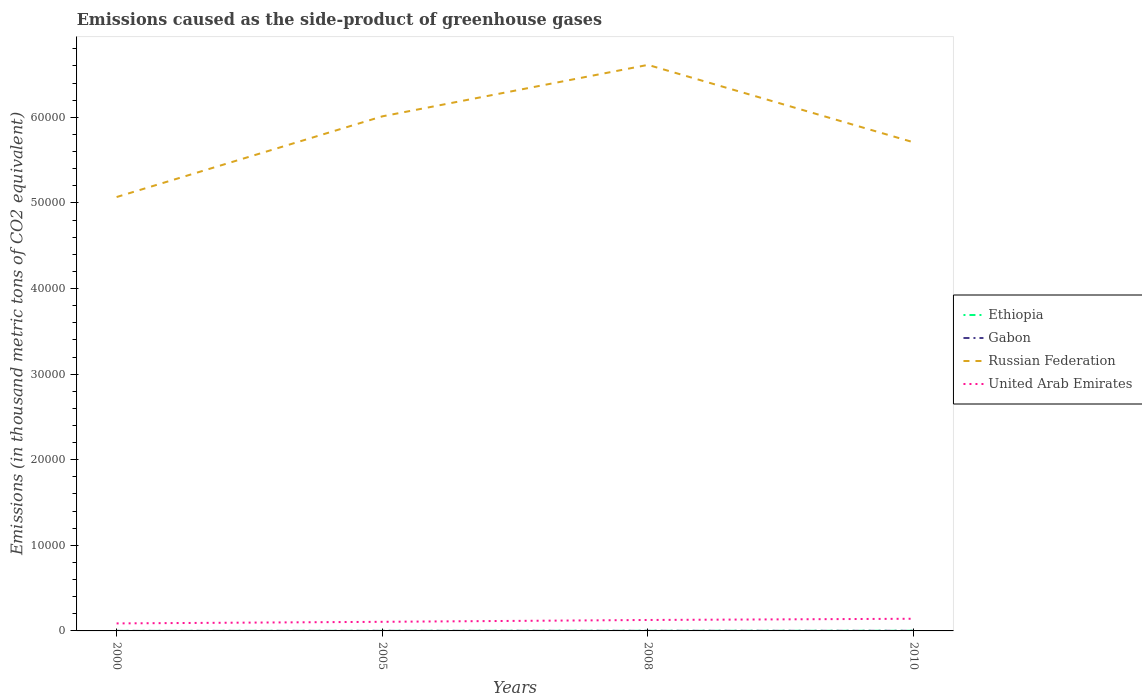How many different coloured lines are there?
Your answer should be very brief. 4. Does the line corresponding to Ethiopia intersect with the line corresponding to United Arab Emirates?
Offer a terse response. No. Across all years, what is the maximum emissions caused as the side-product of greenhouse gases in Russian Federation?
Make the answer very short. 5.07e+04. In which year was the emissions caused as the side-product of greenhouse gases in Ethiopia maximum?
Give a very brief answer. 2000. What is the total emissions caused as the side-product of greenhouse gases in Ethiopia in the graph?
Give a very brief answer. -3. What is the difference between the highest and the second highest emissions caused as the side-product of greenhouse gases in Gabon?
Provide a succinct answer. 11.1. What is the difference between two consecutive major ticks on the Y-axis?
Your answer should be compact. 10000. Are the values on the major ticks of Y-axis written in scientific E-notation?
Make the answer very short. No. Does the graph contain any zero values?
Offer a very short reply. No. Where does the legend appear in the graph?
Offer a very short reply. Center right. How many legend labels are there?
Offer a very short reply. 4. What is the title of the graph?
Offer a very short reply. Emissions caused as the side-product of greenhouse gases. What is the label or title of the Y-axis?
Offer a very short reply. Emissions (in thousand metric tons of CO2 equivalent). What is the Emissions (in thousand metric tons of CO2 equivalent) in Ethiopia in 2000?
Ensure brevity in your answer.  3.6. What is the Emissions (in thousand metric tons of CO2 equivalent) of Russian Federation in 2000?
Provide a short and direct response. 5.07e+04. What is the Emissions (in thousand metric tons of CO2 equivalent) in United Arab Emirates in 2000?
Your response must be concise. 878.1. What is the Emissions (in thousand metric tons of CO2 equivalent) of Russian Federation in 2005?
Your answer should be very brief. 6.01e+04. What is the Emissions (in thousand metric tons of CO2 equivalent) of United Arab Emirates in 2005?
Provide a succinct answer. 1064.1. What is the Emissions (in thousand metric tons of CO2 equivalent) of Russian Federation in 2008?
Provide a succinct answer. 6.61e+04. What is the Emissions (in thousand metric tons of CO2 equivalent) in United Arab Emirates in 2008?
Your response must be concise. 1279. What is the Emissions (in thousand metric tons of CO2 equivalent) of Ethiopia in 2010?
Ensure brevity in your answer.  16. What is the Emissions (in thousand metric tons of CO2 equivalent) of Gabon in 2010?
Keep it short and to the point. 14. What is the Emissions (in thousand metric tons of CO2 equivalent) in Russian Federation in 2010?
Offer a very short reply. 5.71e+04. What is the Emissions (in thousand metric tons of CO2 equivalent) of United Arab Emirates in 2010?
Keep it short and to the point. 1422. Across all years, what is the maximum Emissions (in thousand metric tons of CO2 equivalent) of Ethiopia?
Your answer should be compact. 16. Across all years, what is the maximum Emissions (in thousand metric tons of CO2 equivalent) of Gabon?
Provide a short and direct response. 14. Across all years, what is the maximum Emissions (in thousand metric tons of CO2 equivalent) of Russian Federation?
Provide a short and direct response. 6.61e+04. Across all years, what is the maximum Emissions (in thousand metric tons of CO2 equivalent) in United Arab Emirates?
Your answer should be compact. 1422. Across all years, what is the minimum Emissions (in thousand metric tons of CO2 equivalent) in Ethiopia?
Your response must be concise. 3.6. Across all years, what is the minimum Emissions (in thousand metric tons of CO2 equivalent) of Russian Federation?
Your answer should be very brief. 5.07e+04. Across all years, what is the minimum Emissions (in thousand metric tons of CO2 equivalent) in United Arab Emirates?
Your answer should be very brief. 878.1. What is the total Emissions (in thousand metric tons of CO2 equivalent) of Ethiopia in the graph?
Provide a short and direct response. 43.2. What is the total Emissions (in thousand metric tons of CO2 equivalent) of Gabon in the graph?
Your response must be concise. 37.1. What is the total Emissions (in thousand metric tons of CO2 equivalent) in Russian Federation in the graph?
Your answer should be very brief. 2.34e+05. What is the total Emissions (in thousand metric tons of CO2 equivalent) in United Arab Emirates in the graph?
Ensure brevity in your answer.  4643.2. What is the difference between the Emissions (in thousand metric tons of CO2 equivalent) of Gabon in 2000 and that in 2005?
Your answer should be very brief. -5.5. What is the difference between the Emissions (in thousand metric tons of CO2 equivalent) in Russian Federation in 2000 and that in 2005?
Keep it short and to the point. -9424.5. What is the difference between the Emissions (in thousand metric tons of CO2 equivalent) of United Arab Emirates in 2000 and that in 2005?
Give a very brief answer. -186. What is the difference between the Emissions (in thousand metric tons of CO2 equivalent) in Ethiopia in 2000 and that in 2008?
Your response must be concise. -9.7. What is the difference between the Emissions (in thousand metric tons of CO2 equivalent) in Russian Federation in 2000 and that in 2008?
Your response must be concise. -1.54e+04. What is the difference between the Emissions (in thousand metric tons of CO2 equivalent) in United Arab Emirates in 2000 and that in 2008?
Give a very brief answer. -400.9. What is the difference between the Emissions (in thousand metric tons of CO2 equivalent) in Russian Federation in 2000 and that in 2010?
Ensure brevity in your answer.  -6391. What is the difference between the Emissions (in thousand metric tons of CO2 equivalent) of United Arab Emirates in 2000 and that in 2010?
Offer a very short reply. -543.9. What is the difference between the Emissions (in thousand metric tons of CO2 equivalent) of Gabon in 2005 and that in 2008?
Ensure brevity in your answer.  -3.4. What is the difference between the Emissions (in thousand metric tons of CO2 equivalent) in Russian Federation in 2005 and that in 2008?
Your answer should be compact. -6015. What is the difference between the Emissions (in thousand metric tons of CO2 equivalent) in United Arab Emirates in 2005 and that in 2008?
Your response must be concise. -214.9. What is the difference between the Emissions (in thousand metric tons of CO2 equivalent) of Gabon in 2005 and that in 2010?
Provide a short and direct response. -5.6. What is the difference between the Emissions (in thousand metric tons of CO2 equivalent) of Russian Federation in 2005 and that in 2010?
Ensure brevity in your answer.  3033.5. What is the difference between the Emissions (in thousand metric tons of CO2 equivalent) of United Arab Emirates in 2005 and that in 2010?
Your answer should be very brief. -357.9. What is the difference between the Emissions (in thousand metric tons of CO2 equivalent) of Gabon in 2008 and that in 2010?
Your answer should be compact. -2.2. What is the difference between the Emissions (in thousand metric tons of CO2 equivalent) in Russian Federation in 2008 and that in 2010?
Keep it short and to the point. 9048.5. What is the difference between the Emissions (in thousand metric tons of CO2 equivalent) of United Arab Emirates in 2008 and that in 2010?
Your response must be concise. -143. What is the difference between the Emissions (in thousand metric tons of CO2 equivalent) in Ethiopia in 2000 and the Emissions (in thousand metric tons of CO2 equivalent) in Russian Federation in 2005?
Provide a short and direct response. -6.01e+04. What is the difference between the Emissions (in thousand metric tons of CO2 equivalent) of Ethiopia in 2000 and the Emissions (in thousand metric tons of CO2 equivalent) of United Arab Emirates in 2005?
Offer a terse response. -1060.5. What is the difference between the Emissions (in thousand metric tons of CO2 equivalent) of Gabon in 2000 and the Emissions (in thousand metric tons of CO2 equivalent) of Russian Federation in 2005?
Keep it short and to the point. -6.01e+04. What is the difference between the Emissions (in thousand metric tons of CO2 equivalent) of Gabon in 2000 and the Emissions (in thousand metric tons of CO2 equivalent) of United Arab Emirates in 2005?
Keep it short and to the point. -1061.2. What is the difference between the Emissions (in thousand metric tons of CO2 equivalent) of Russian Federation in 2000 and the Emissions (in thousand metric tons of CO2 equivalent) of United Arab Emirates in 2005?
Offer a terse response. 4.96e+04. What is the difference between the Emissions (in thousand metric tons of CO2 equivalent) of Ethiopia in 2000 and the Emissions (in thousand metric tons of CO2 equivalent) of Russian Federation in 2008?
Your answer should be very brief. -6.61e+04. What is the difference between the Emissions (in thousand metric tons of CO2 equivalent) in Ethiopia in 2000 and the Emissions (in thousand metric tons of CO2 equivalent) in United Arab Emirates in 2008?
Keep it short and to the point. -1275.4. What is the difference between the Emissions (in thousand metric tons of CO2 equivalent) in Gabon in 2000 and the Emissions (in thousand metric tons of CO2 equivalent) in Russian Federation in 2008?
Offer a very short reply. -6.61e+04. What is the difference between the Emissions (in thousand metric tons of CO2 equivalent) in Gabon in 2000 and the Emissions (in thousand metric tons of CO2 equivalent) in United Arab Emirates in 2008?
Provide a short and direct response. -1276.1. What is the difference between the Emissions (in thousand metric tons of CO2 equivalent) of Russian Federation in 2000 and the Emissions (in thousand metric tons of CO2 equivalent) of United Arab Emirates in 2008?
Provide a succinct answer. 4.94e+04. What is the difference between the Emissions (in thousand metric tons of CO2 equivalent) of Ethiopia in 2000 and the Emissions (in thousand metric tons of CO2 equivalent) of Russian Federation in 2010?
Keep it short and to the point. -5.71e+04. What is the difference between the Emissions (in thousand metric tons of CO2 equivalent) in Ethiopia in 2000 and the Emissions (in thousand metric tons of CO2 equivalent) in United Arab Emirates in 2010?
Your answer should be very brief. -1418.4. What is the difference between the Emissions (in thousand metric tons of CO2 equivalent) in Gabon in 2000 and the Emissions (in thousand metric tons of CO2 equivalent) in Russian Federation in 2010?
Your answer should be compact. -5.71e+04. What is the difference between the Emissions (in thousand metric tons of CO2 equivalent) in Gabon in 2000 and the Emissions (in thousand metric tons of CO2 equivalent) in United Arab Emirates in 2010?
Your answer should be very brief. -1419.1. What is the difference between the Emissions (in thousand metric tons of CO2 equivalent) in Russian Federation in 2000 and the Emissions (in thousand metric tons of CO2 equivalent) in United Arab Emirates in 2010?
Keep it short and to the point. 4.93e+04. What is the difference between the Emissions (in thousand metric tons of CO2 equivalent) in Ethiopia in 2005 and the Emissions (in thousand metric tons of CO2 equivalent) in Gabon in 2008?
Offer a very short reply. -1.5. What is the difference between the Emissions (in thousand metric tons of CO2 equivalent) in Ethiopia in 2005 and the Emissions (in thousand metric tons of CO2 equivalent) in Russian Federation in 2008?
Your answer should be compact. -6.61e+04. What is the difference between the Emissions (in thousand metric tons of CO2 equivalent) of Ethiopia in 2005 and the Emissions (in thousand metric tons of CO2 equivalent) of United Arab Emirates in 2008?
Provide a short and direct response. -1268.7. What is the difference between the Emissions (in thousand metric tons of CO2 equivalent) of Gabon in 2005 and the Emissions (in thousand metric tons of CO2 equivalent) of Russian Federation in 2008?
Your answer should be very brief. -6.61e+04. What is the difference between the Emissions (in thousand metric tons of CO2 equivalent) of Gabon in 2005 and the Emissions (in thousand metric tons of CO2 equivalent) of United Arab Emirates in 2008?
Your response must be concise. -1270.6. What is the difference between the Emissions (in thousand metric tons of CO2 equivalent) of Russian Federation in 2005 and the Emissions (in thousand metric tons of CO2 equivalent) of United Arab Emirates in 2008?
Your response must be concise. 5.88e+04. What is the difference between the Emissions (in thousand metric tons of CO2 equivalent) in Ethiopia in 2005 and the Emissions (in thousand metric tons of CO2 equivalent) in Russian Federation in 2010?
Offer a terse response. -5.71e+04. What is the difference between the Emissions (in thousand metric tons of CO2 equivalent) of Ethiopia in 2005 and the Emissions (in thousand metric tons of CO2 equivalent) of United Arab Emirates in 2010?
Keep it short and to the point. -1411.7. What is the difference between the Emissions (in thousand metric tons of CO2 equivalent) in Gabon in 2005 and the Emissions (in thousand metric tons of CO2 equivalent) in Russian Federation in 2010?
Ensure brevity in your answer.  -5.71e+04. What is the difference between the Emissions (in thousand metric tons of CO2 equivalent) of Gabon in 2005 and the Emissions (in thousand metric tons of CO2 equivalent) of United Arab Emirates in 2010?
Ensure brevity in your answer.  -1413.6. What is the difference between the Emissions (in thousand metric tons of CO2 equivalent) of Russian Federation in 2005 and the Emissions (in thousand metric tons of CO2 equivalent) of United Arab Emirates in 2010?
Keep it short and to the point. 5.87e+04. What is the difference between the Emissions (in thousand metric tons of CO2 equivalent) of Ethiopia in 2008 and the Emissions (in thousand metric tons of CO2 equivalent) of Gabon in 2010?
Give a very brief answer. -0.7. What is the difference between the Emissions (in thousand metric tons of CO2 equivalent) in Ethiopia in 2008 and the Emissions (in thousand metric tons of CO2 equivalent) in Russian Federation in 2010?
Make the answer very short. -5.71e+04. What is the difference between the Emissions (in thousand metric tons of CO2 equivalent) of Ethiopia in 2008 and the Emissions (in thousand metric tons of CO2 equivalent) of United Arab Emirates in 2010?
Your answer should be compact. -1408.7. What is the difference between the Emissions (in thousand metric tons of CO2 equivalent) of Gabon in 2008 and the Emissions (in thousand metric tons of CO2 equivalent) of Russian Federation in 2010?
Give a very brief answer. -5.71e+04. What is the difference between the Emissions (in thousand metric tons of CO2 equivalent) of Gabon in 2008 and the Emissions (in thousand metric tons of CO2 equivalent) of United Arab Emirates in 2010?
Provide a succinct answer. -1410.2. What is the difference between the Emissions (in thousand metric tons of CO2 equivalent) of Russian Federation in 2008 and the Emissions (in thousand metric tons of CO2 equivalent) of United Arab Emirates in 2010?
Offer a very short reply. 6.47e+04. What is the average Emissions (in thousand metric tons of CO2 equivalent) in Ethiopia per year?
Make the answer very short. 10.8. What is the average Emissions (in thousand metric tons of CO2 equivalent) of Gabon per year?
Provide a short and direct response. 9.28. What is the average Emissions (in thousand metric tons of CO2 equivalent) in Russian Federation per year?
Offer a terse response. 5.85e+04. What is the average Emissions (in thousand metric tons of CO2 equivalent) of United Arab Emirates per year?
Your response must be concise. 1160.8. In the year 2000, what is the difference between the Emissions (in thousand metric tons of CO2 equivalent) in Ethiopia and Emissions (in thousand metric tons of CO2 equivalent) in Gabon?
Provide a short and direct response. 0.7. In the year 2000, what is the difference between the Emissions (in thousand metric tons of CO2 equivalent) in Ethiopia and Emissions (in thousand metric tons of CO2 equivalent) in Russian Federation?
Your answer should be very brief. -5.07e+04. In the year 2000, what is the difference between the Emissions (in thousand metric tons of CO2 equivalent) in Ethiopia and Emissions (in thousand metric tons of CO2 equivalent) in United Arab Emirates?
Offer a terse response. -874.5. In the year 2000, what is the difference between the Emissions (in thousand metric tons of CO2 equivalent) in Gabon and Emissions (in thousand metric tons of CO2 equivalent) in Russian Federation?
Make the answer very short. -5.07e+04. In the year 2000, what is the difference between the Emissions (in thousand metric tons of CO2 equivalent) of Gabon and Emissions (in thousand metric tons of CO2 equivalent) of United Arab Emirates?
Ensure brevity in your answer.  -875.2. In the year 2000, what is the difference between the Emissions (in thousand metric tons of CO2 equivalent) in Russian Federation and Emissions (in thousand metric tons of CO2 equivalent) in United Arab Emirates?
Offer a very short reply. 4.98e+04. In the year 2005, what is the difference between the Emissions (in thousand metric tons of CO2 equivalent) in Ethiopia and Emissions (in thousand metric tons of CO2 equivalent) in Gabon?
Your answer should be very brief. 1.9. In the year 2005, what is the difference between the Emissions (in thousand metric tons of CO2 equivalent) of Ethiopia and Emissions (in thousand metric tons of CO2 equivalent) of Russian Federation?
Ensure brevity in your answer.  -6.01e+04. In the year 2005, what is the difference between the Emissions (in thousand metric tons of CO2 equivalent) in Ethiopia and Emissions (in thousand metric tons of CO2 equivalent) in United Arab Emirates?
Your answer should be very brief. -1053.8. In the year 2005, what is the difference between the Emissions (in thousand metric tons of CO2 equivalent) in Gabon and Emissions (in thousand metric tons of CO2 equivalent) in Russian Federation?
Offer a terse response. -6.01e+04. In the year 2005, what is the difference between the Emissions (in thousand metric tons of CO2 equivalent) in Gabon and Emissions (in thousand metric tons of CO2 equivalent) in United Arab Emirates?
Make the answer very short. -1055.7. In the year 2005, what is the difference between the Emissions (in thousand metric tons of CO2 equivalent) of Russian Federation and Emissions (in thousand metric tons of CO2 equivalent) of United Arab Emirates?
Your answer should be compact. 5.90e+04. In the year 2008, what is the difference between the Emissions (in thousand metric tons of CO2 equivalent) in Ethiopia and Emissions (in thousand metric tons of CO2 equivalent) in Russian Federation?
Ensure brevity in your answer.  -6.61e+04. In the year 2008, what is the difference between the Emissions (in thousand metric tons of CO2 equivalent) in Ethiopia and Emissions (in thousand metric tons of CO2 equivalent) in United Arab Emirates?
Make the answer very short. -1265.7. In the year 2008, what is the difference between the Emissions (in thousand metric tons of CO2 equivalent) of Gabon and Emissions (in thousand metric tons of CO2 equivalent) of Russian Federation?
Your answer should be very brief. -6.61e+04. In the year 2008, what is the difference between the Emissions (in thousand metric tons of CO2 equivalent) of Gabon and Emissions (in thousand metric tons of CO2 equivalent) of United Arab Emirates?
Give a very brief answer. -1267.2. In the year 2008, what is the difference between the Emissions (in thousand metric tons of CO2 equivalent) in Russian Federation and Emissions (in thousand metric tons of CO2 equivalent) in United Arab Emirates?
Make the answer very short. 6.48e+04. In the year 2010, what is the difference between the Emissions (in thousand metric tons of CO2 equivalent) of Ethiopia and Emissions (in thousand metric tons of CO2 equivalent) of Gabon?
Provide a short and direct response. 2. In the year 2010, what is the difference between the Emissions (in thousand metric tons of CO2 equivalent) in Ethiopia and Emissions (in thousand metric tons of CO2 equivalent) in Russian Federation?
Your answer should be compact. -5.71e+04. In the year 2010, what is the difference between the Emissions (in thousand metric tons of CO2 equivalent) of Ethiopia and Emissions (in thousand metric tons of CO2 equivalent) of United Arab Emirates?
Make the answer very short. -1406. In the year 2010, what is the difference between the Emissions (in thousand metric tons of CO2 equivalent) of Gabon and Emissions (in thousand metric tons of CO2 equivalent) of Russian Federation?
Your answer should be very brief. -5.71e+04. In the year 2010, what is the difference between the Emissions (in thousand metric tons of CO2 equivalent) in Gabon and Emissions (in thousand metric tons of CO2 equivalent) in United Arab Emirates?
Give a very brief answer. -1408. In the year 2010, what is the difference between the Emissions (in thousand metric tons of CO2 equivalent) in Russian Federation and Emissions (in thousand metric tons of CO2 equivalent) in United Arab Emirates?
Give a very brief answer. 5.57e+04. What is the ratio of the Emissions (in thousand metric tons of CO2 equivalent) of Ethiopia in 2000 to that in 2005?
Provide a short and direct response. 0.35. What is the ratio of the Emissions (in thousand metric tons of CO2 equivalent) of Gabon in 2000 to that in 2005?
Provide a succinct answer. 0.35. What is the ratio of the Emissions (in thousand metric tons of CO2 equivalent) of Russian Federation in 2000 to that in 2005?
Your answer should be very brief. 0.84. What is the ratio of the Emissions (in thousand metric tons of CO2 equivalent) in United Arab Emirates in 2000 to that in 2005?
Give a very brief answer. 0.83. What is the ratio of the Emissions (in thousand metric tons of CO2 equivalent) in Ethiopia in 2000 to that in 2008?
Offer a terse response. 0.27. What is the ratio of the Emissions (in thousand metric tons of CO2 equivalent) in Gabon in 2000 to that in 2008?
Give a very brief answer. 0.25. What is the ratio of the Emissions (in thousand metric tons of CO2 equivalent) in Russian Federation in 2000 to that in 2008?
Offer a terse response. 0.77. What is the ratio of the Emissions (in thousand metric tons of CO2 equivalent) in United Arab Emirates in 2000 to that in 2008?
Make the answer very short. 0.69. What is the ratio of the Emissions (in thousand metric tons of CO2 equivalent) in Ethiopia in 2000 to that in 2010?
Make the answer very short. 0.23. What is the ratio of the Emissions (in thousand metric tons of CO2 equivalent) in Gabon in 2000 to that in 2010?
Offer a terse response. 0.21. What is the ratio of the Emissions (in thousand metric tons of CO2 equivalent) of Russian Federation in 2000 to that in 2010?
Keep it short and to the point. 0.89. What is the ratio of the Emissions (in thousand metric tons of CO2 equivalent) of United Arab Emirates in 2000 to that in 2010?
Provide a short and direct response. 0.62. What is the ratio of the Emissions (in thousand metric tons of CO2 equivalent) of Ethiopia in 2005 to that in 2008?
Your answer should be compact. 0.77. What is the ratio of the Emissions (in thousand metric tons of CO2 equivalent) of Gabon in 2005 to that in 2008?
Provide a short and direct response. 0.71. What is the ratio of the Emissions (in thousand metric tons of CO2 equivalent) in Russian Federation in 2005 to that in 2008?
Your answer should be very brief. 0.91. What is the ratio of the Emissions (in thousand metric tons of CO2 equivalent) of United Arab Emirates in 2005 to that in 2008?
Your answer should be very brief. 0.83. What is the ratio of the Emissions (in thousand metric tons of CO2 equivalent) of Ethiopia in 2005 to that in 2010?
Your answer should be very brief. 0.64. What is the ratio of the Emissions (in thousand metric tons of CO2 equivalent) in Russian Federation in 2005 to that in 2010?
Your answer should be compact. 1.05. What is the ratio of the Emissions (in thousand metric tons of CO2 equivalent) in United Arab Emirates in 2005 to that in 2010?
Offer a very short reply. 0.75. What is the ratio of the Emissions (in thousand metric tons of CO2 equivalent) of Ethiopia in 2008 to that in 2010?
Provide a short and direct response. 0.83. What is the ratio of the Emissions (in thousand metric tons of CO2 equivalent) in Gabon in 2008 to that in 2010?
Provide a succinct answer. 0.84. What is the ratio of the Emissions (in thousand metric tons of CO2 equivalent) of Russian Federation in 2008 to that in 2010?
Your answer should be very brief. 1.16. What is the ratio of the Emissions (in thousand metric tons of CO2 equivalent) of United Arab Emirates in 2008 to that in 2010?
Provide a succinct answer. 0.9. What is the difference between the highest and the second highest Emissions (in thousand metric tons of CO2 equivalent) in Ethiopia?
Offer a very short reply. 2.7. What is the difference between the highest and the second highest Emissions (in thousand metric tons of CO2 equivalent) of Gabon?
Give a very brief answer. 2.2. What is the difference between the highest and the second highest Emissions (in thousand metric tons of CO2 equivalent) in Russian Federation?
Your answer should be compact. 6015. What is the difference between the highest and the second highest Emissions (in thousand metric tons of CO2 equivalent) of United Arab Emirates?
Ensure brevity in your answer.  143. What is the difference between the highest and the lowest Emissions (in thousand metric tons of CO2 equivalent) in Ethiopia?
Provide a succinct answer. 12.4. What is the difference between the highest and the lowest Emissions (in thousand metric tons of CO2 equivalent) in Russian Federation?
Provide a succinct answer. 1.54e+04. What is the difference between the highest and the lowest Emissions (in thousand metric tons of CO2 equivalent) of United Arab Emirates?
Keep it short and to the point. 543.9. 